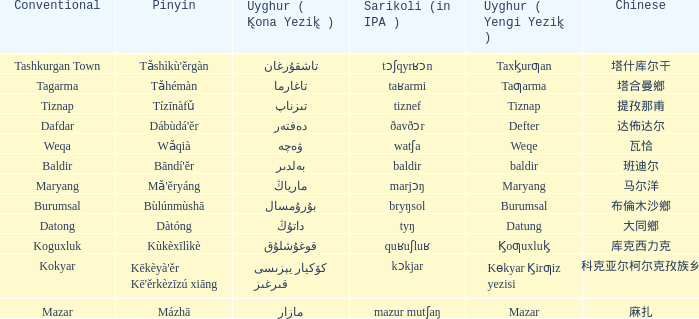Name the pinyin for mazar Mázhā. 